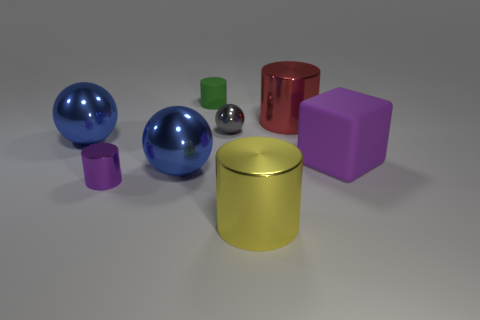Subtract 1 cylinders. How many cylinders are left? 3 Add 1 small purple cylinders. How many objects exist? 9 Subtract all gray cylinders. Subtract all cyan balls. How many cylinders are left? 4 Subtract all blocks. How many objects are left? 7 Add 3 blue metal spheres. How many blue metal spheres exist? 5 Subtract 2 blue balls. How many objects are left? 6 Subtract all big brown cylinders. Subtract all small purple metal objects. How many objects are left? 7 Add 7 small shiny cylinders. How many small shiny cylinders are left? 8 